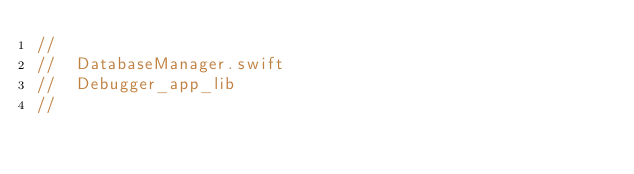Convert code to text. <code><loc_0><loc_0><loc_500><loc_500><_Swift_>//
//  DatabaseManager.swift
//  Debugger_app_lib
//</code> 